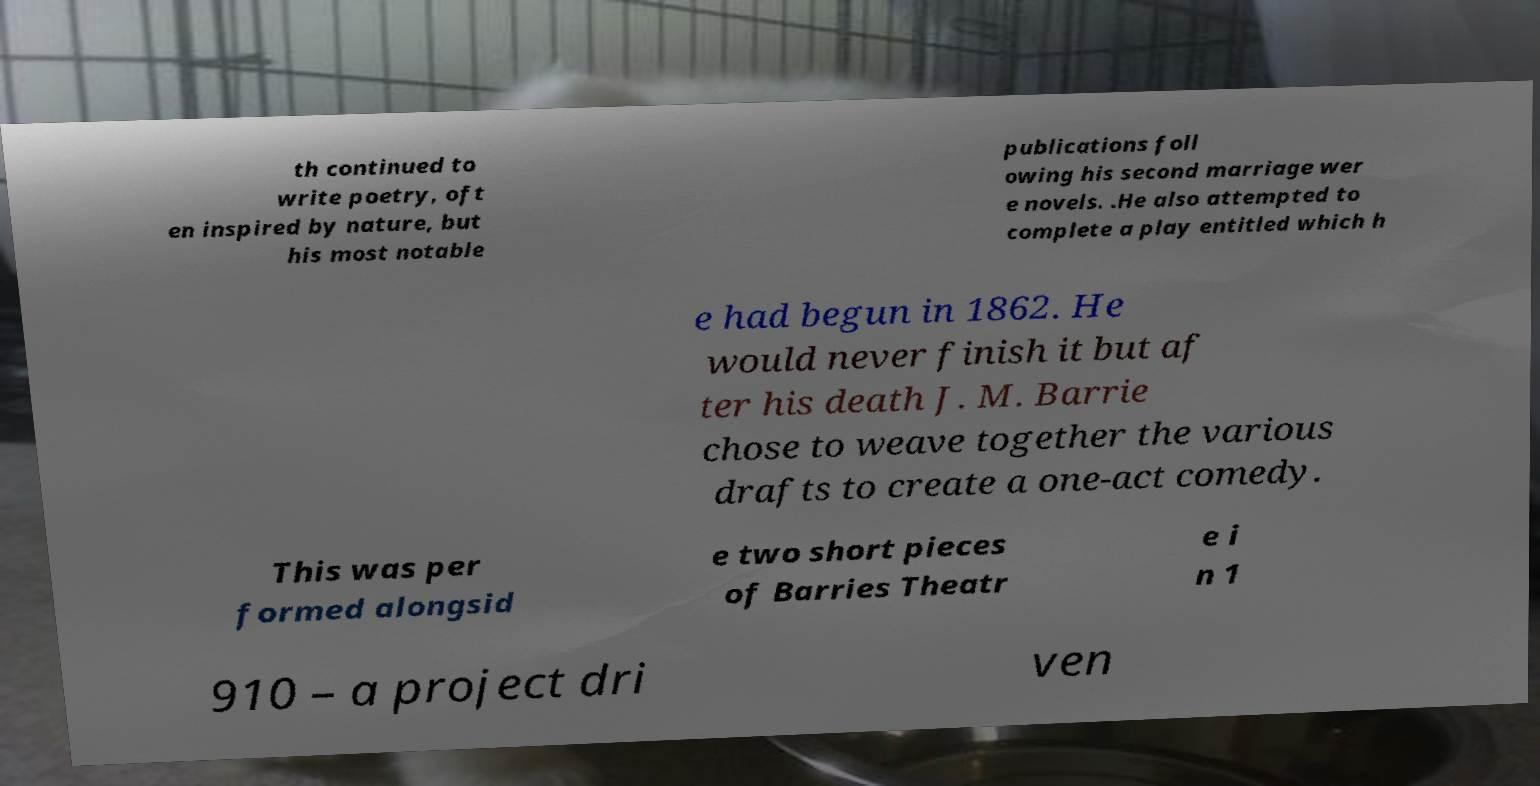Please identify and transcribe the text found in this image. th continued to write poetry, oft en inspired by nature, but his most notable publications foll owing his second marriage wer e novels. .He also attempted to complete a play entitled which h e had begun in 1862. He would never finish it but af ter his death J. M. Barrie chose to weave together the various drafts to create a one-act comedy. This was per formed alongsid e two short pieces of Barries Theatr e i n 1 910 – a project dri ven 